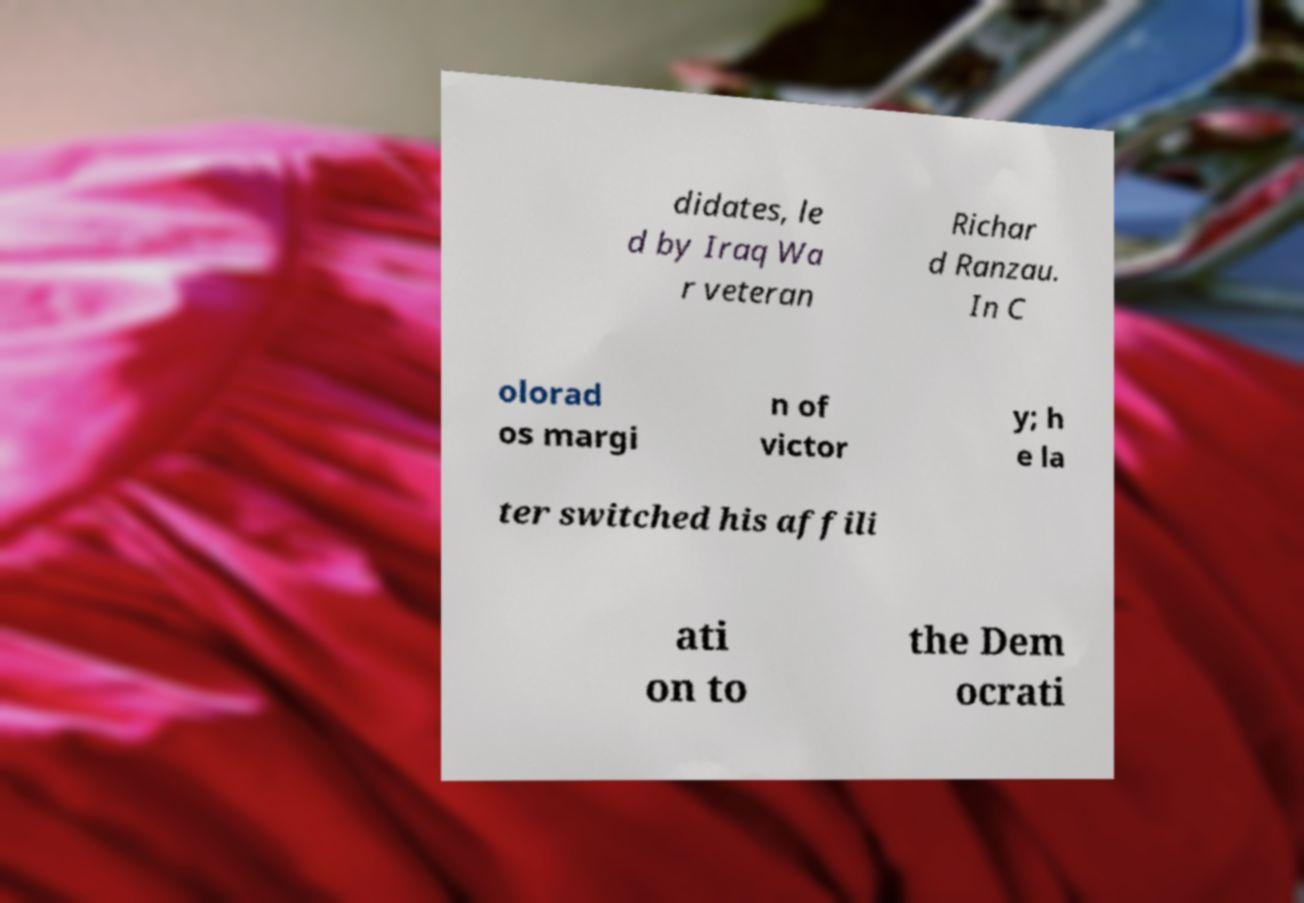Please read and relay the text visible in this image. What does it say? didates, le d by Iraq Wa r veteran Richar d Ranzau. In C olorad os margi n of victor y; h e la ter switched his affili ati on to the Dem ocrati 